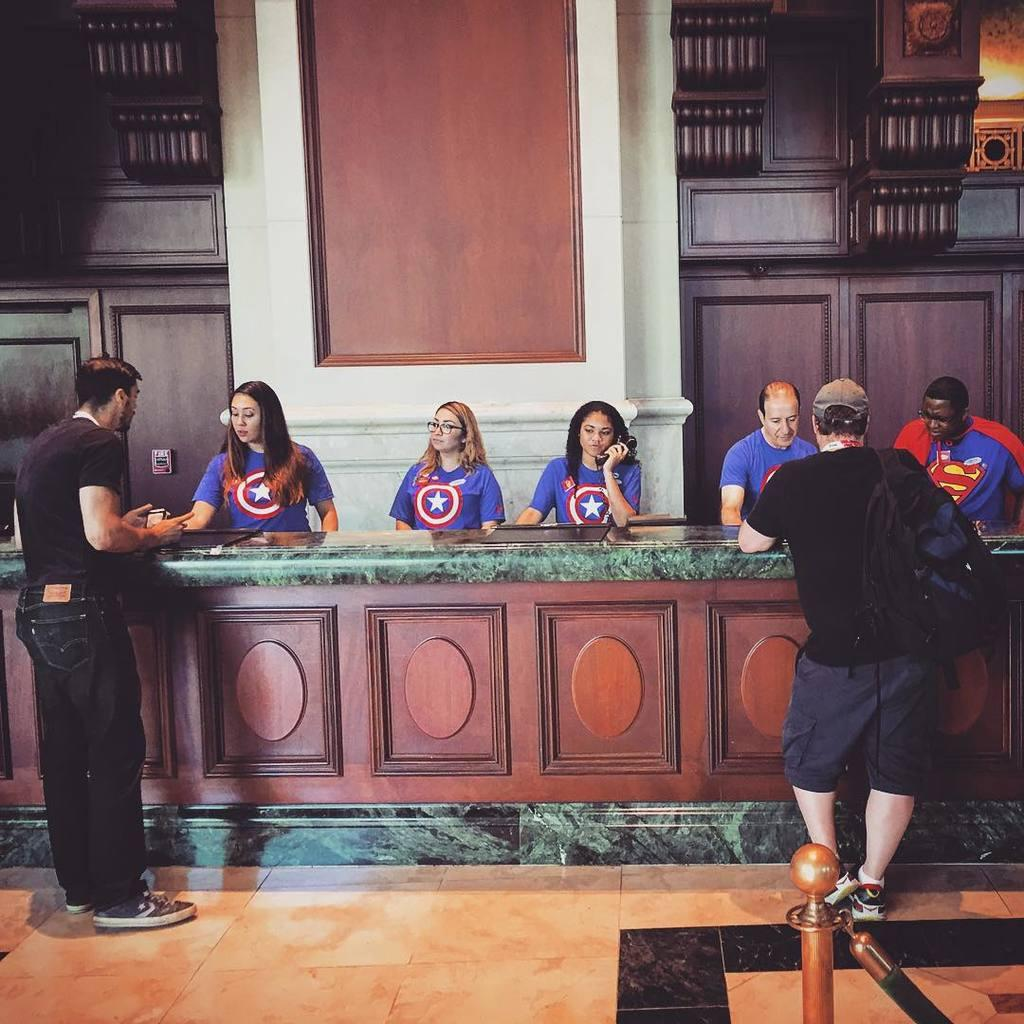What is happening in the image? There are people standing in the image. Can you describe the setting of the image? The image shows an inner view of a building. What type of plough is being used by the sister in the image? There is no sister or plough present in the image. 